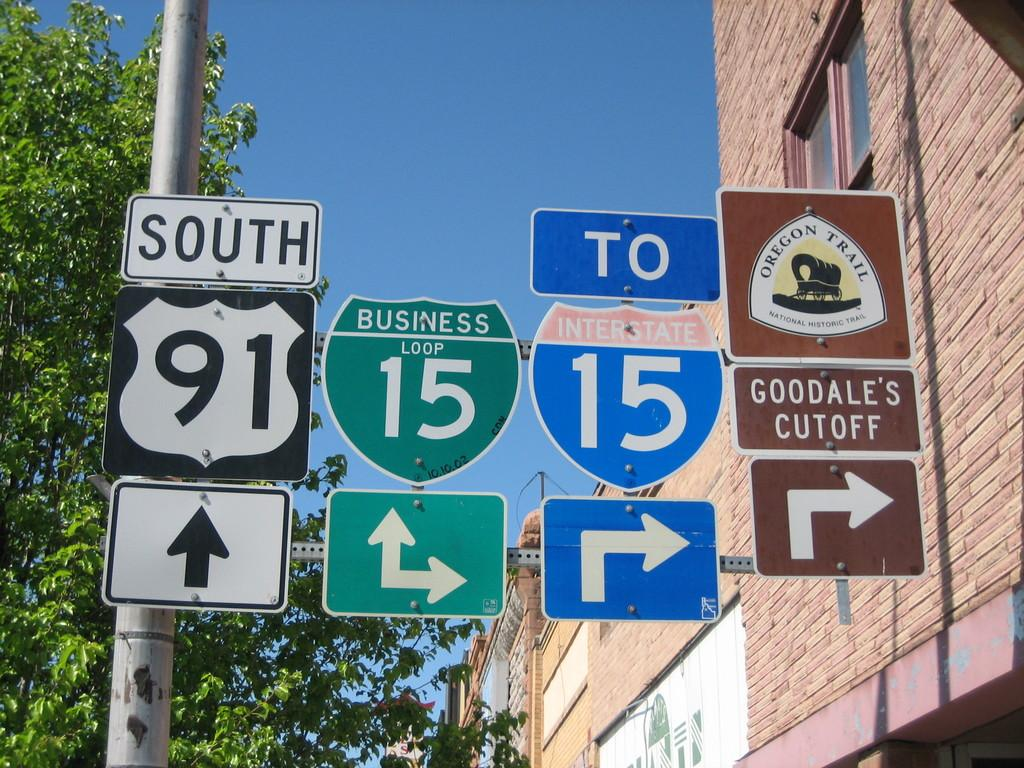<image>
Render a clear and concise summary of the photo. A picture of a 4 road signs giving directions to goodales cutoff. 